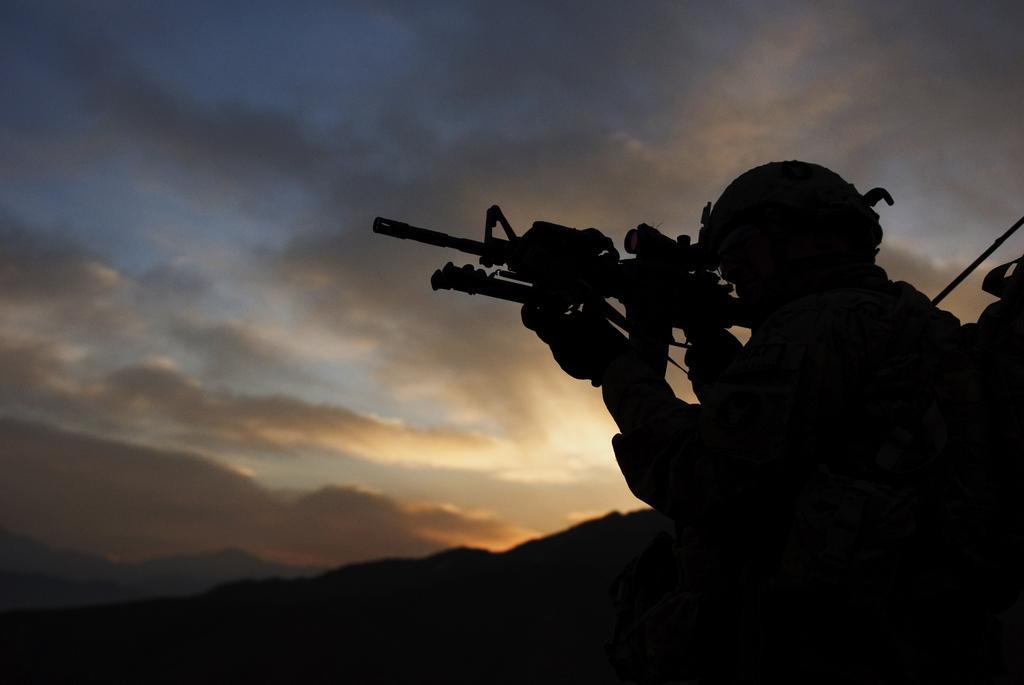How would you summarize this image in a sentence or two? In this image on the right side there is one person who is wearing uniform and he is holding a gun, and also he is wearing a bag and in the background there are mountains. At the top there is sky. 